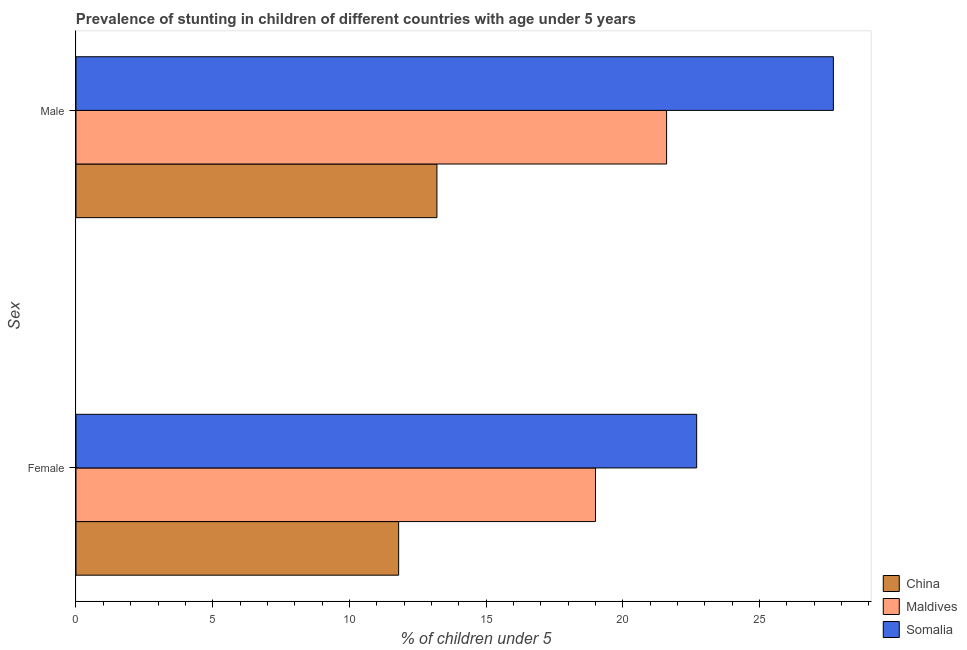Are the number of bars on each tick of the Y-axis equal?
Offer a very short reply. Yes. How many bars are there on the 2nd tick from the top?
Make the answer very short. 3. How many bars are there on the 1st tick from the bottom?
Give a very brief answer. 3. What is the percentage of stunted male children in Maldives?
Give a very brief answer. 21.6. Across all countries, what is the maximum percentage of stunted male children?
Your response must be concise. 27.7. Across all countries, what is the minimum percentage of stunted female children?
Ensure brevity in your answer.  11.8. In which country was the percentage of stunted male children maximum?
Offer a very short reply. Somalia. What is the total percentage of stunted female children in the graph?
Make the answer very short. 53.5. What is the difference between the percentage of stunted male children in Maldives and that in Somalia?
Your answer should be compact. -6.1. What is the difference between the percentage of stunted male children in China and the percentage of stunted female children in Maldives?
Your response must be concise. -5.8. What is the average percentage of stunted male children per country?
Provide a short and direct response. 20.83. What is the difference between the percentage of stunted female children and percentage of stunted male children in Maldives?
Your answer should be very brief. -2.6. What is the ratio of the percentage of stunted male children in Somalia to that in China?
Offer a very short reply. 2.1. In how many countries, is the percentage of stunted female children greater than the average percentage of stunted female children taken over all countries?
Offer a very short reply. 2. What does the 3rd bar from the bottom in Female represents?
Ensure brevity in your answer.  Somalia. How many bars are there?
Keep it short and to the point. 6. Are all the bars in the graph horizontal?
Make the answer very short. Yes. How many countries are there in the graph?
Your answer should be very brief. 3. What is the difference between two consecutive major ticks on the X-axis?
Ensure brevity in your answer.  5. Does the graph contain any zero values?
Provide a succinct answer. No. Does the graph contain grids?
Provide a succinct answer. No. How many legend labels are there?
Keep it short and to the point. 3. How are the legend labels stacked?
Your response must be concise. Vertical. What is the title of the graph?
Keep it short and to the point. Prevalence of stunting in children of different countries with age under 5 years. Does "American Samoa" appear as one of the legend labels in the graph?
Ensure brevity in your answer.  No. What is the label or title of the X-axis?
Your answer should be very brief.  % of children under 5. What is the label or title of the Y-axis?
Your response must be concise. Sex. What is the  % of children under 5 in China in Female?
Provide a succinct answer. 11.8. What is the  % of children under 5 in Somalia in Female?
Your response must be concise. 22.7. What is the  % of children under 5 of China in Male?
Offer a terse response. 13.2. What is the  % of children under 5 in Maldives in Male?
Provide a succinct answer. 21.6. What is the  % of children under 5 in Somalia in Male?
Make the answer very short. 27.7. Across all Sex, what is the maximum  % of children under 5 in China?
Offer a terse response. 13.2. Across all Sex, what is the maximum  % of children under 5 of Maldives?
Provide a short and direct response. 21.6. Across all Sex, what is the maximum  % of children under 5 in Somalia?
Keep it short and to the point. 27.7. Across all Sex, what is the minimum  % of children under 5 of China?
Make the answer very short. 11.8. Across all Sex, what is the minimum  % of children under 5 of Maldives?
Offer a very short reply. 19. Across all Sex, what is the minimum  % of children under 5 in Somalia?
Provide a succinct answer. 22.7. What is the total  % of children under 5 in Maldives in the graph?
Ensure brevity in your answer.  40.6. What is the total  % of children under 5 of Somalia in the graph?
Give a very brief answer. 50.4. What is the difference between the  % of children under 5 in Maldives in Female and that in Male?
Your response must be concise. -2.6. What is the difference between the  % of children under 5 in Somalia in Female and that in Male?
Offer a very short reply. -5. What is the difference between the  % of children under 5 in China in Female and the  % of children under 5 in Maldives in Male?
Offer a terse response. -9.8. What is the difference between the  % of children under 5 of China in Female and the  % of children under 5 of Somalia in Male?
Ensure brevity in your answer.  -15.9. What is the difference between the  % of children under 5 in Maldives in Female and the  % of children under 5 in Somalia in Male?
Keep it short and to the point. -8.7. What is the average  % of children under 5 of Maldives per Sex?
Offer a terse response. 20.3. What is the average  % of children under 5 of Somalia per Sex?
Your answer should be very brief. 25.2. What is the difference between the  % of children under 5 of China and  % of children under 5 of Maldives in Female?
Keep it short and to the point. -7.2. What is the difference between the  % of children under 5 in China and  % of children under 5 in Maldives in Male?
Your answer should be compact. -8.4. What is the difference between the  % of children under 5 of China and  % of children under 5 of Somalia in Male?
Provide a succinct answer. -14.5. What is the ratio of the  % of children under 5 of China in Female to that in Male?
Ensure brevity in your answer.  0.89. What is the ratio of the  % of children under 5 of Maldives in Female to that in Male?
Provide a short and direct response. 0.88. What is the ratio of the  % of children under 5 of Somalia in Female to that in Male?
Ensure brevity in your answer.  0.82. What is the difference between the highest and the second highest  % of children under 5 in Somalia?
Your response must be concise. 5. What is the difference between the highest and the lowest  % of children under 5 of Maldives?
Ensure brevity in your answer.  2.6. What is the difference between the highest and the lowest  % of children under 5 of Somalia?
Give a very brief answer. 5. 